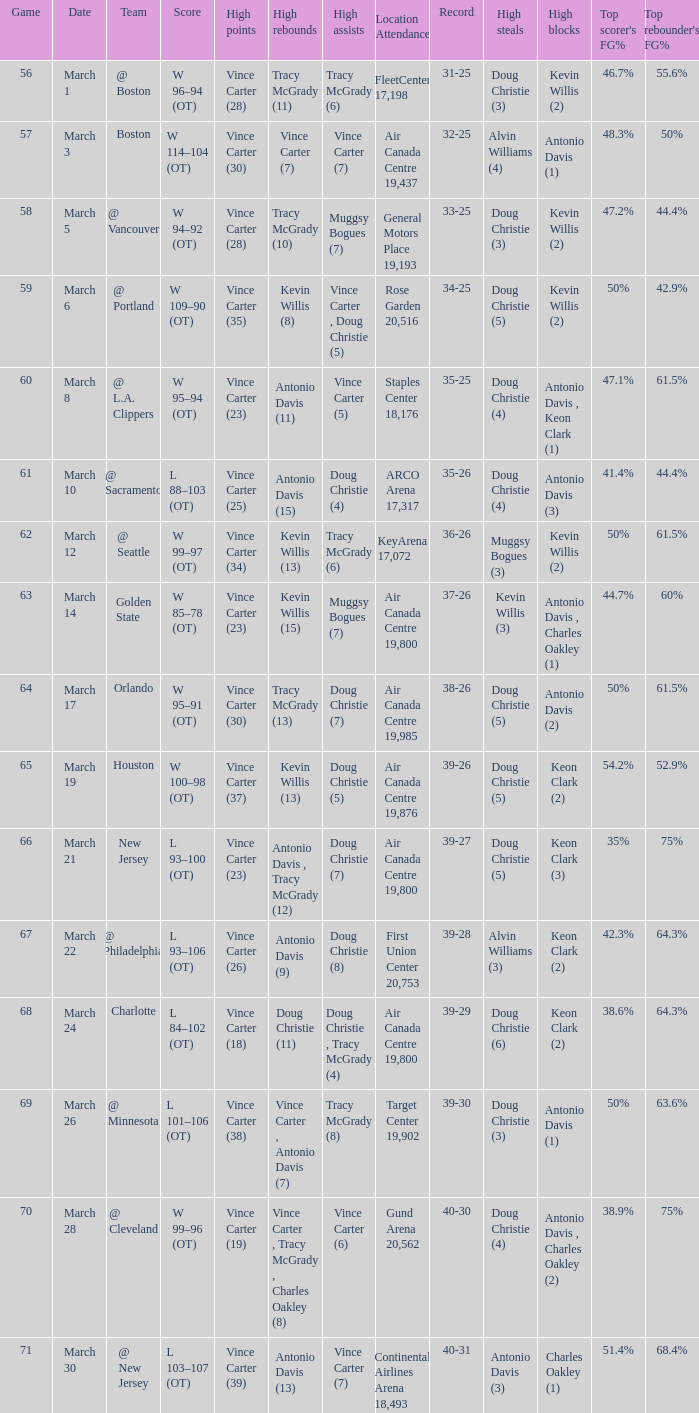Where did the team play and what was the attendance against new jersey? Air Canada Centre 19,800. Can you give me this table as a dict? {'header': ['Game', 'Date', 'Team', 'Score', 'High points', 'High rebounds', 'High assists', 'Location Attendance', 'Record', 'High steals', 'High blocks', "Top scorer's FG%", "Top rebounder's FG% "], 'rows': [['56', 'March 1', '@ Boston', 'W 96–94 (OT)', 'Vince Carter (28)', 'Tracy McGrady (11)', 'Tracy McGrady (6)', 'FleetCenter 17,198', '31-25', 'Doug Christie (3)', 'Kevin Willis (2)', '46.7%', '55.6%'], ['57', 'March 3', 'Boston', 'W 114–104 (OT)', 'Vince Carter (30)', 'Vince Carter (7)', 'Vince Carter (7)', 'Air Canada Centre 19,437', '32-25', 'Alvin Williams (4)', 'Antonio Davis (1)', '48.3%', '50%'], ['58', 'March 5', '@ Vancouver', 'W 94–92 (OT)', 'Vince Carter (28)', 'Tracy McGrady (10)', 'Muggsy Bogues (7)', 'General Motors Place 19,193', '33-25', 'Doug Christie (3)', 'Kevin Willis (2)', '47.2%', '44.4%'], ['59', 'March 6', '@ Portland', 'W 109–90 (OT)', 'Vince Carter (35)', 'Kevin Willis (8)', 'Vince Carter , Doug Christie (5)', 'Rose Garden 20,516', '34-25', 'Doug Christie (5)', 'Kevin Willis (2)', '50%', '42.9%'], ['60', 'March 8', '@ L.A. Clippers', 'W 95–94 (OT)', 'Vince Carter (23)', 'Antonio Davis (11)', 'Vince Carter (5)', 'Staples Center 18,176', '35-25', 'Doug Christie (4)', 'Antonio Davis , Keon Clark (1)', '47.1%', '61.5%'], ['61', 'March 10', '@ Sacramento', 'L 88–103 (OT)', 'Vince Carter (25)', 'Antonio Davis (15)', 'Doug Christie (4)', 'ARCO Arena 17,317', '35-26', 'Doug Christie (4)', 'Antonio Davis (3)', '41.4%', '44.4%'], ['62', 'March 12', '@ Seattle', 'W 99–97 (OT)', 'Vince Carter (34)', 'Kevin Willis (13)', 'Tracy McGrady (6)', 'KeyArena 17,072', '36-26', 'Muggsy Bogues (3)', 'Kevin Willis (2)', '50%', '61.5%'], ['63', 'March 14', 'Golden State', 'W 85–78 (OT)', 'Vince Carter (23)', 'Kevin Willis (15)', 'Muggsy Bogues (7)', 'Air Canada Centre 19,800', '37-26', 'Kevin Willis (3)', 'Antonio Davis , Charles Oakley (1)', '44.7%', '60%'], ['64', 'March 17', 'Orlando', 'W 95–91 (OT)', 'Vince Carter (30)', 'Tracy McGrady (13)', 'Doug Christie (7)', 'Air Canada Centre 19,985', '38-26', 'Doug Christie (5)', 'Antonio Davis (2)', '50%', '61.5%'], ['65', 'March 19', 'Houston', 'W 100–98 (OT)', 'Vince Carter (37)', 'Kevin Willis (13)', 'Doug Christie (5)', 'Air Canada Centre 19,876', '39-26', 'Doug Christie (5)', 'Keon Clark (2)', '54.2%', '52.9%'], ['66', 'March 21', 'New Jersey', 'L 93–100 (OT)', 'Vince Carter (23)', 'Antonio Davis , Tracy McGrady (12)', 'Doug Christie (7)', 'Air Canada Centre 19,800', '39-27', 'Doug Christie (5)', 'Keon Clark (3)', '35%', '75%'], ['67', 'March 22', '@ Philadelphia', 'L 93–106 (OT)', 'Vince Carter (26)', 'Antonio Davis (9)', 'Doug Christie (8)', 'First Union Center 20,753', '39-28', 'Alvin Williams (3)', 'Keon Clark (2)', '42.3%', '64.3%'], ['68', 'March 24', 'Charlotte', 'L 84–102 (OT)', 'Vince Carter (18)', 'Doug Christie (11)', 'Doug Christie , Tracy McGrady (4)', 'Air Canada Centre 19,800', '39-29', 'Doug Christie (6)', 'Keon Clark (2)', '38.6%', '64.3%'], ['69', 'March 26', '@ Minnesota', 'L 101–106 (OT)', 'Vince Carter (38)', 'Vince Carter , Antonio Davis (7)', 'Tracy McGrady (8)', 'Target Center 19,902', '39-30', 'Doug Christie (3)', 'Antonio Davis (1)', '50%', '63.6%'], ['70', 'March 28', '@ Cleveland', 'W 99–96 (OT)', 'Vince Carter (19)', 'Vince Carter , Tracy McGrady , Charles Oakley (8)', 'Vince Carter (6)', 'Gund Arena 20,562', '40-30', 'Doug Christie (4)', 'Antonio Davis , Charles Oakley (2)', '38.9%', '75%'], ['71', 'March 30', '@ New Jersey', 'L 103–107 (OT)', 'Vince Carter (39)', 'Antonio Davis (13)', 'Vince Carter (7)', 'Continental Airlines Arena 18,493', '40-31', 'Antonio Davis (3)', 'Charles Oakley (1)', '51.4%', '68.4%']]} 